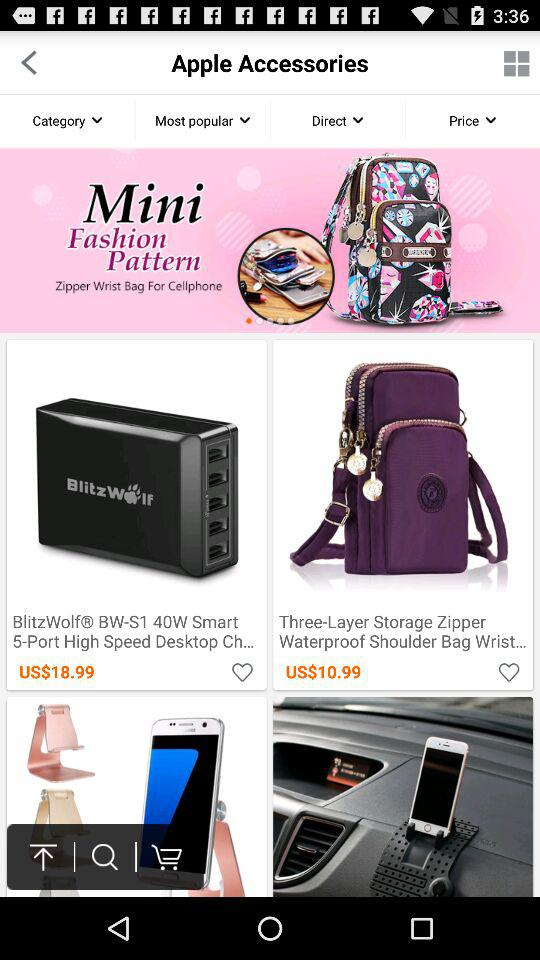What is the price for three layer storage zipper? The price is "$10.99". 